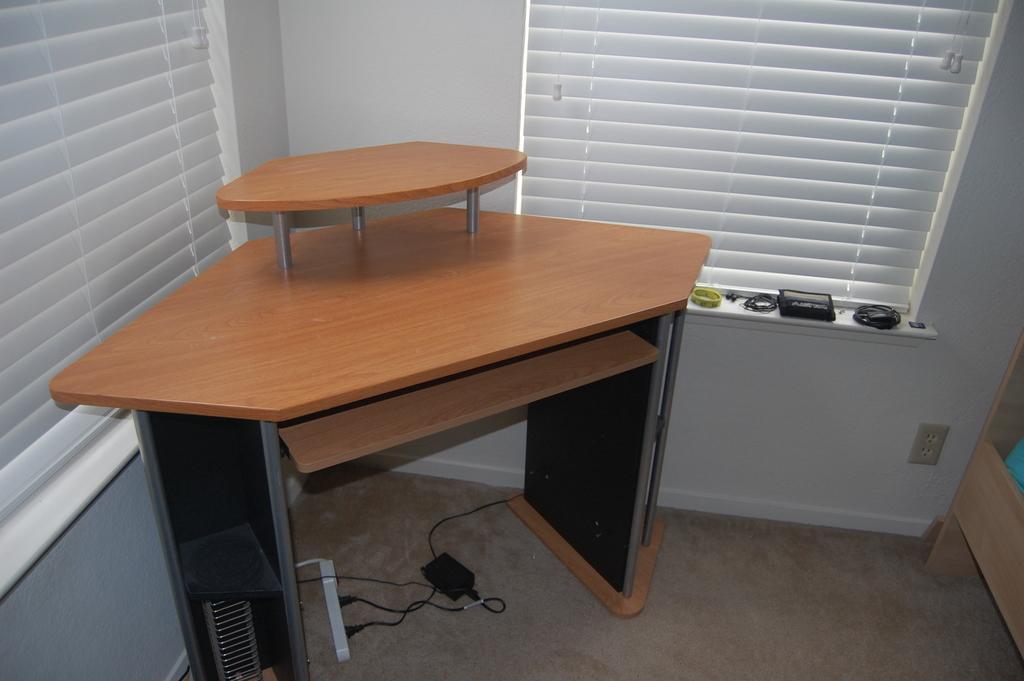In one or two sentences, can you explain what this image depicts? In the image there is a desktop table on the corner of the room with windows on either side of the wall with curtains over it, there is switch board on the floor, there are some accessories in front of the window. 